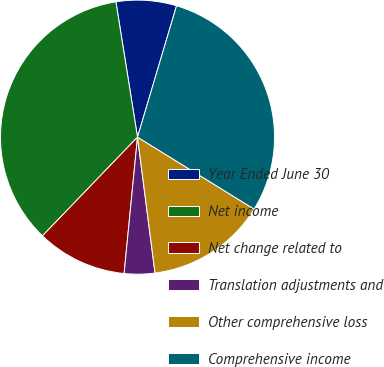Convert chart to OTSL. <chart><loc_0><loc_0><loc_500><loc_500><pie_chart><fcel>Year Ended June 30<fcel>Net income<fcel>Net change related to<fcel>Translation adjustments and<fcel>Other comprehensive loss<fcel>Comprehensive income<nl><fcel>7.12%<fcel>35.28%<fcel>10.64%<fcel>3.6%<fcel>14.16%<fcel>29.2%<nl></chart> 